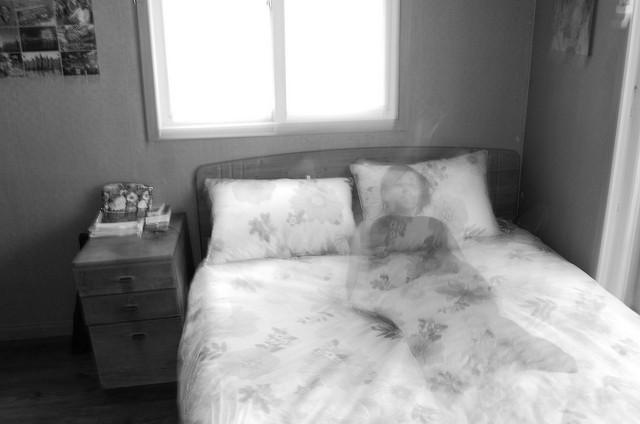The exposure makes the woman look like what?
Choose the correct response, then elucidate: 'Answer: answer
Rationale: rationale.'
Options: Leprechaun, ghost, witch, vampire. Answer: ghost.
Rationale: The woman looks like a ghost due to the camera. 